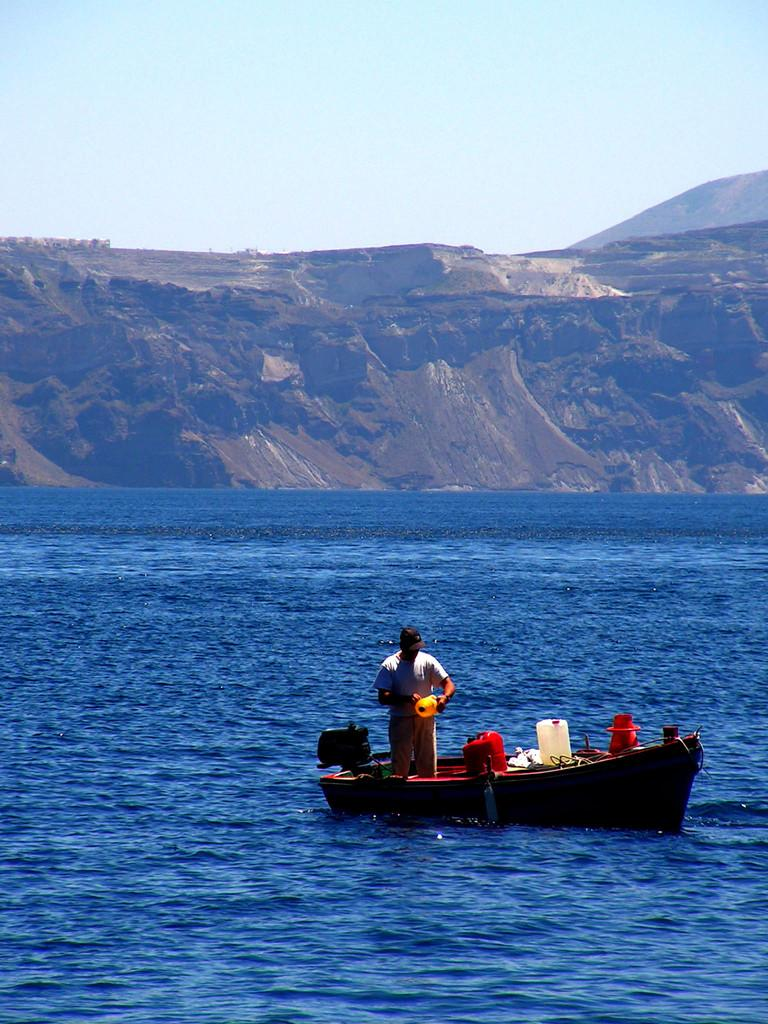What is the main subject of the image? There is a person on a boat in the image. What is the boat floating on? The boat is floating on water. What geographical feature can be seen in the middle of the image? There is a hill in the middle of the image. What is visible at the top of the image? The sky is visible at the top of the image. Can you see a trail leading up the hill in the image? There is no trail visible in the image; only the hill and the boat on the water are present. What color is the person's tongue in the image? There is no indication of the person's tongue in the image, as the focus is on the boat and the surrounding landscape. 